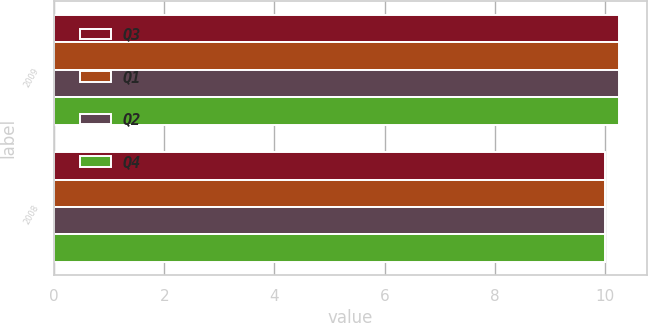Convert chart to OTSL. <chart><loc_0><loc_0><loc_500><loc_500><stacked_bar_chart><ecel><fcel>2009<fcel>2008<nl><fcel>Q3<fcel>10.25<fcel>10<nl><fcel>Q1<fcel>10.25<fcel>10<nl><fcel>Q2<fcel>10.25<fcel>10<nl><fcel>Q4<fcel>10.25<fcel>10<nl></chart> 